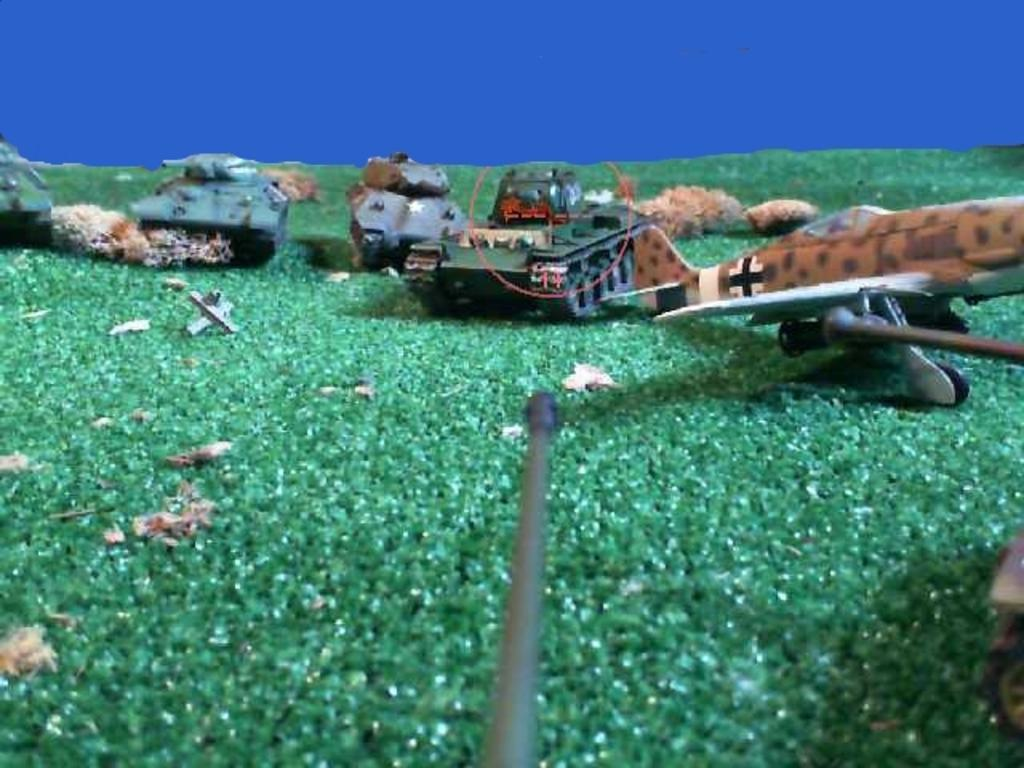What type of toys are present in the image? There are toy vehicles in the image. What else can be seen on the ground in the image? There are other objects on the ground in the image. What can be seen in the background of the image? The sky is visible in the background of the image. What type of bone can be seen in the image? There is no bone present in the image; it features toy vehicles and other objects on the ground. 